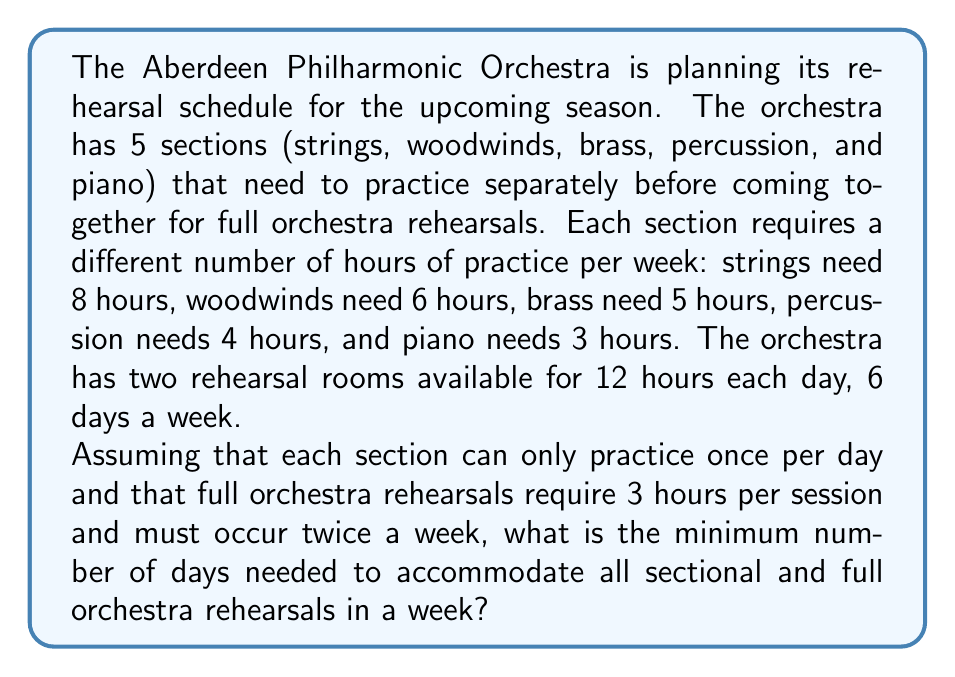Could you help me with this problem? Let's approach this problem step by step:

1. Calculate the total rehearsal hours needed per week:
   * Sectional rehearsals: $8 + 6 + 5 + 4 + 3 = 26$ hours
   * Full orchestra rehearsals: $3 \times 2 = 6$ hours
   * Total: $26 + 6 = 32$ hours

2. Calculate the total available rehearsal time per day:
   * Two rooms for 12 hours each: $2 \times 12 = 24$ hours per day

3. We need to find the minimum number of days ($x$) that satisfies:
   $$ 24x \geq 32 $$

4. Solving for $x$:
   $$ x \geq \frac{32}{24} = \frac{4}{3} = 1.33... $$

5. Since we can only have whole days, we round up to the nearest integer:
   $$ x = 2 \text{ days} $$

6. However, we need to check if this satisfies the constraint that each section can only practice once per day:
   * Day 1: Strings (8h), Woodwinds (6h), Brass (5h), Full orchestra (3h) = 22h
   * Day 2: Percussion (4h), Piano (3h), Full orchestra (3h) = 10h

   This schedule works within the 24-hour daily limit and satisfies all constraints.

Therefore, the minimum number of days needed is 2.
Answer: 2 days 